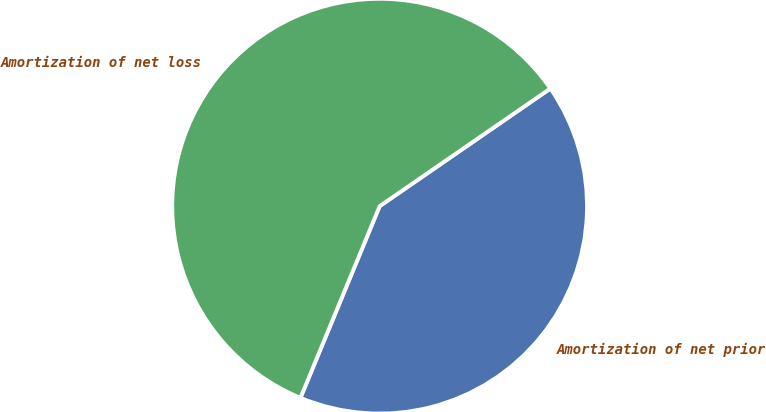Convert chart. <chart><loc_0><loc_0><loc_500><loc_500><pie_chart><fcel>Amortization of net prior<fcel>Amortization of net loss<nl><fcel>40.84%<fcel>59.16%<nl></chart> 